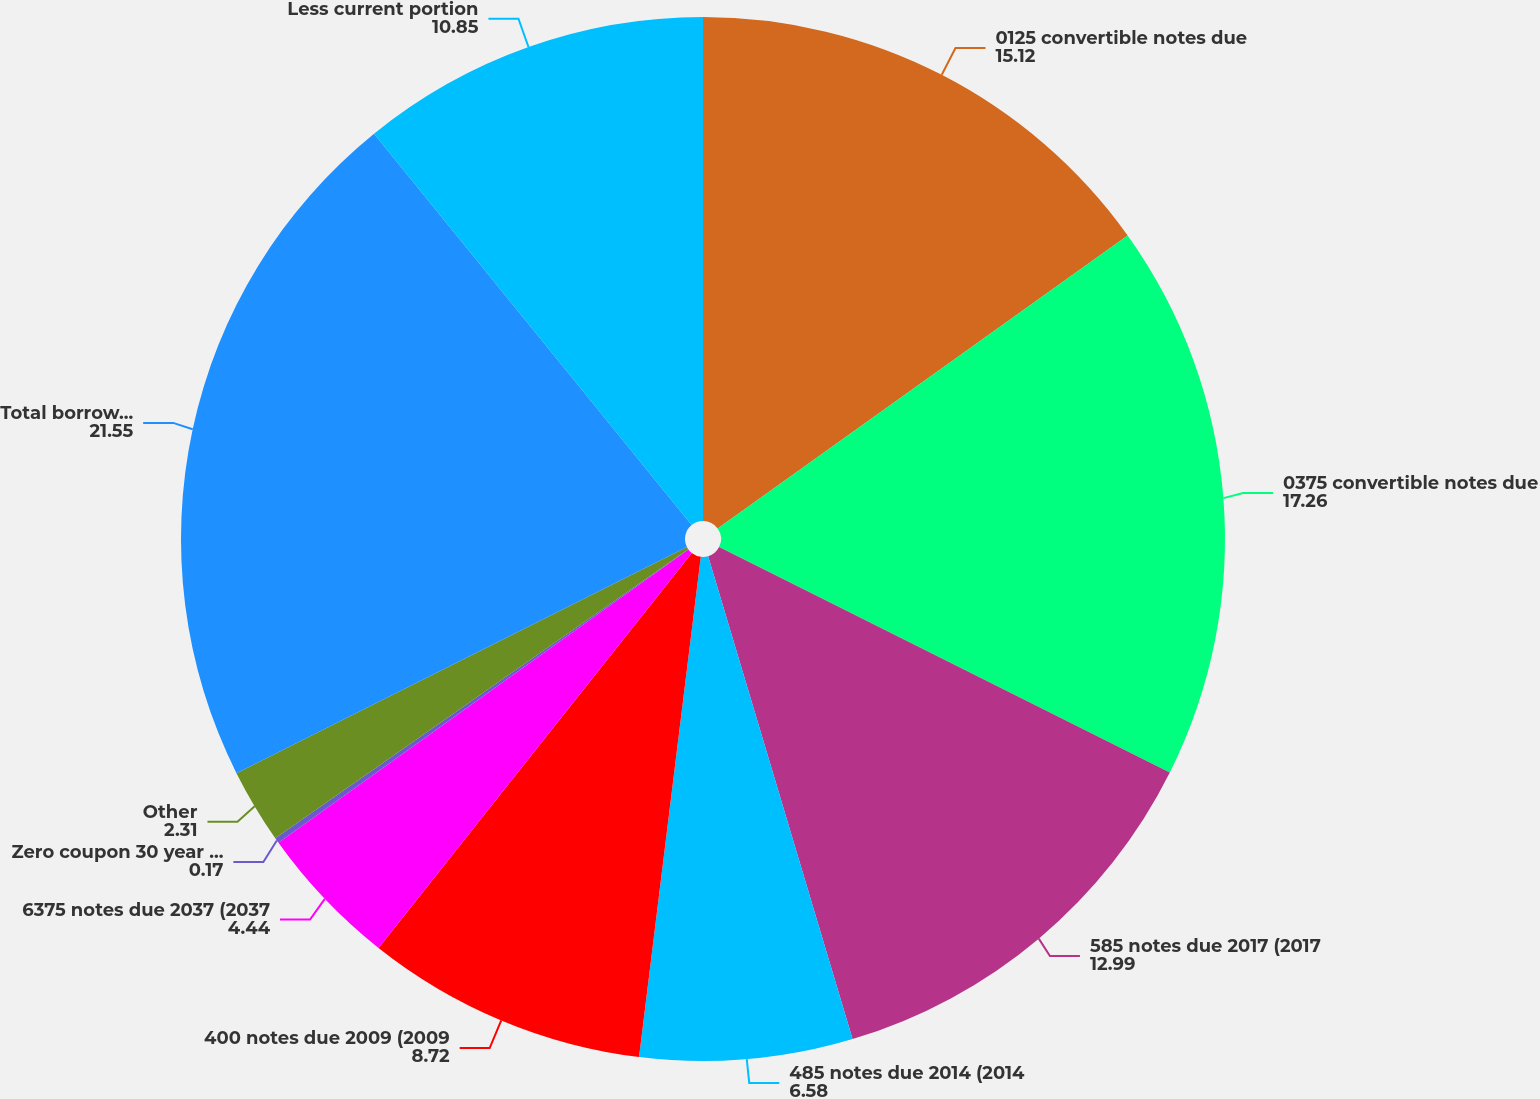Convert chart to OTSL. <chart><loc_0><loc_0><loc_500><loc_500><pie_chart><fcel>0125 convertible notes due<fcel>0375 convertible notes due<fcel>585 notes due 2017 (2017<fcel>485 notes due 2014 (2014<fcel>400 notes due 2009 (2009<fcel>6375 notes due 2037 (2037<fcel>Zero coupon 30 year modified<fcel>Other<fcel>Total borrowings<fcel>Less current portion<nl><fcel>15.12%<fcel>17.26%<fcel>12.99%<fcel>6.58%<fcel>8.72%<fcel>4.44%<fcel>0.17%<fcel>2.31%<fcel>21.55%<fcel>10.85%<nl></chart> 